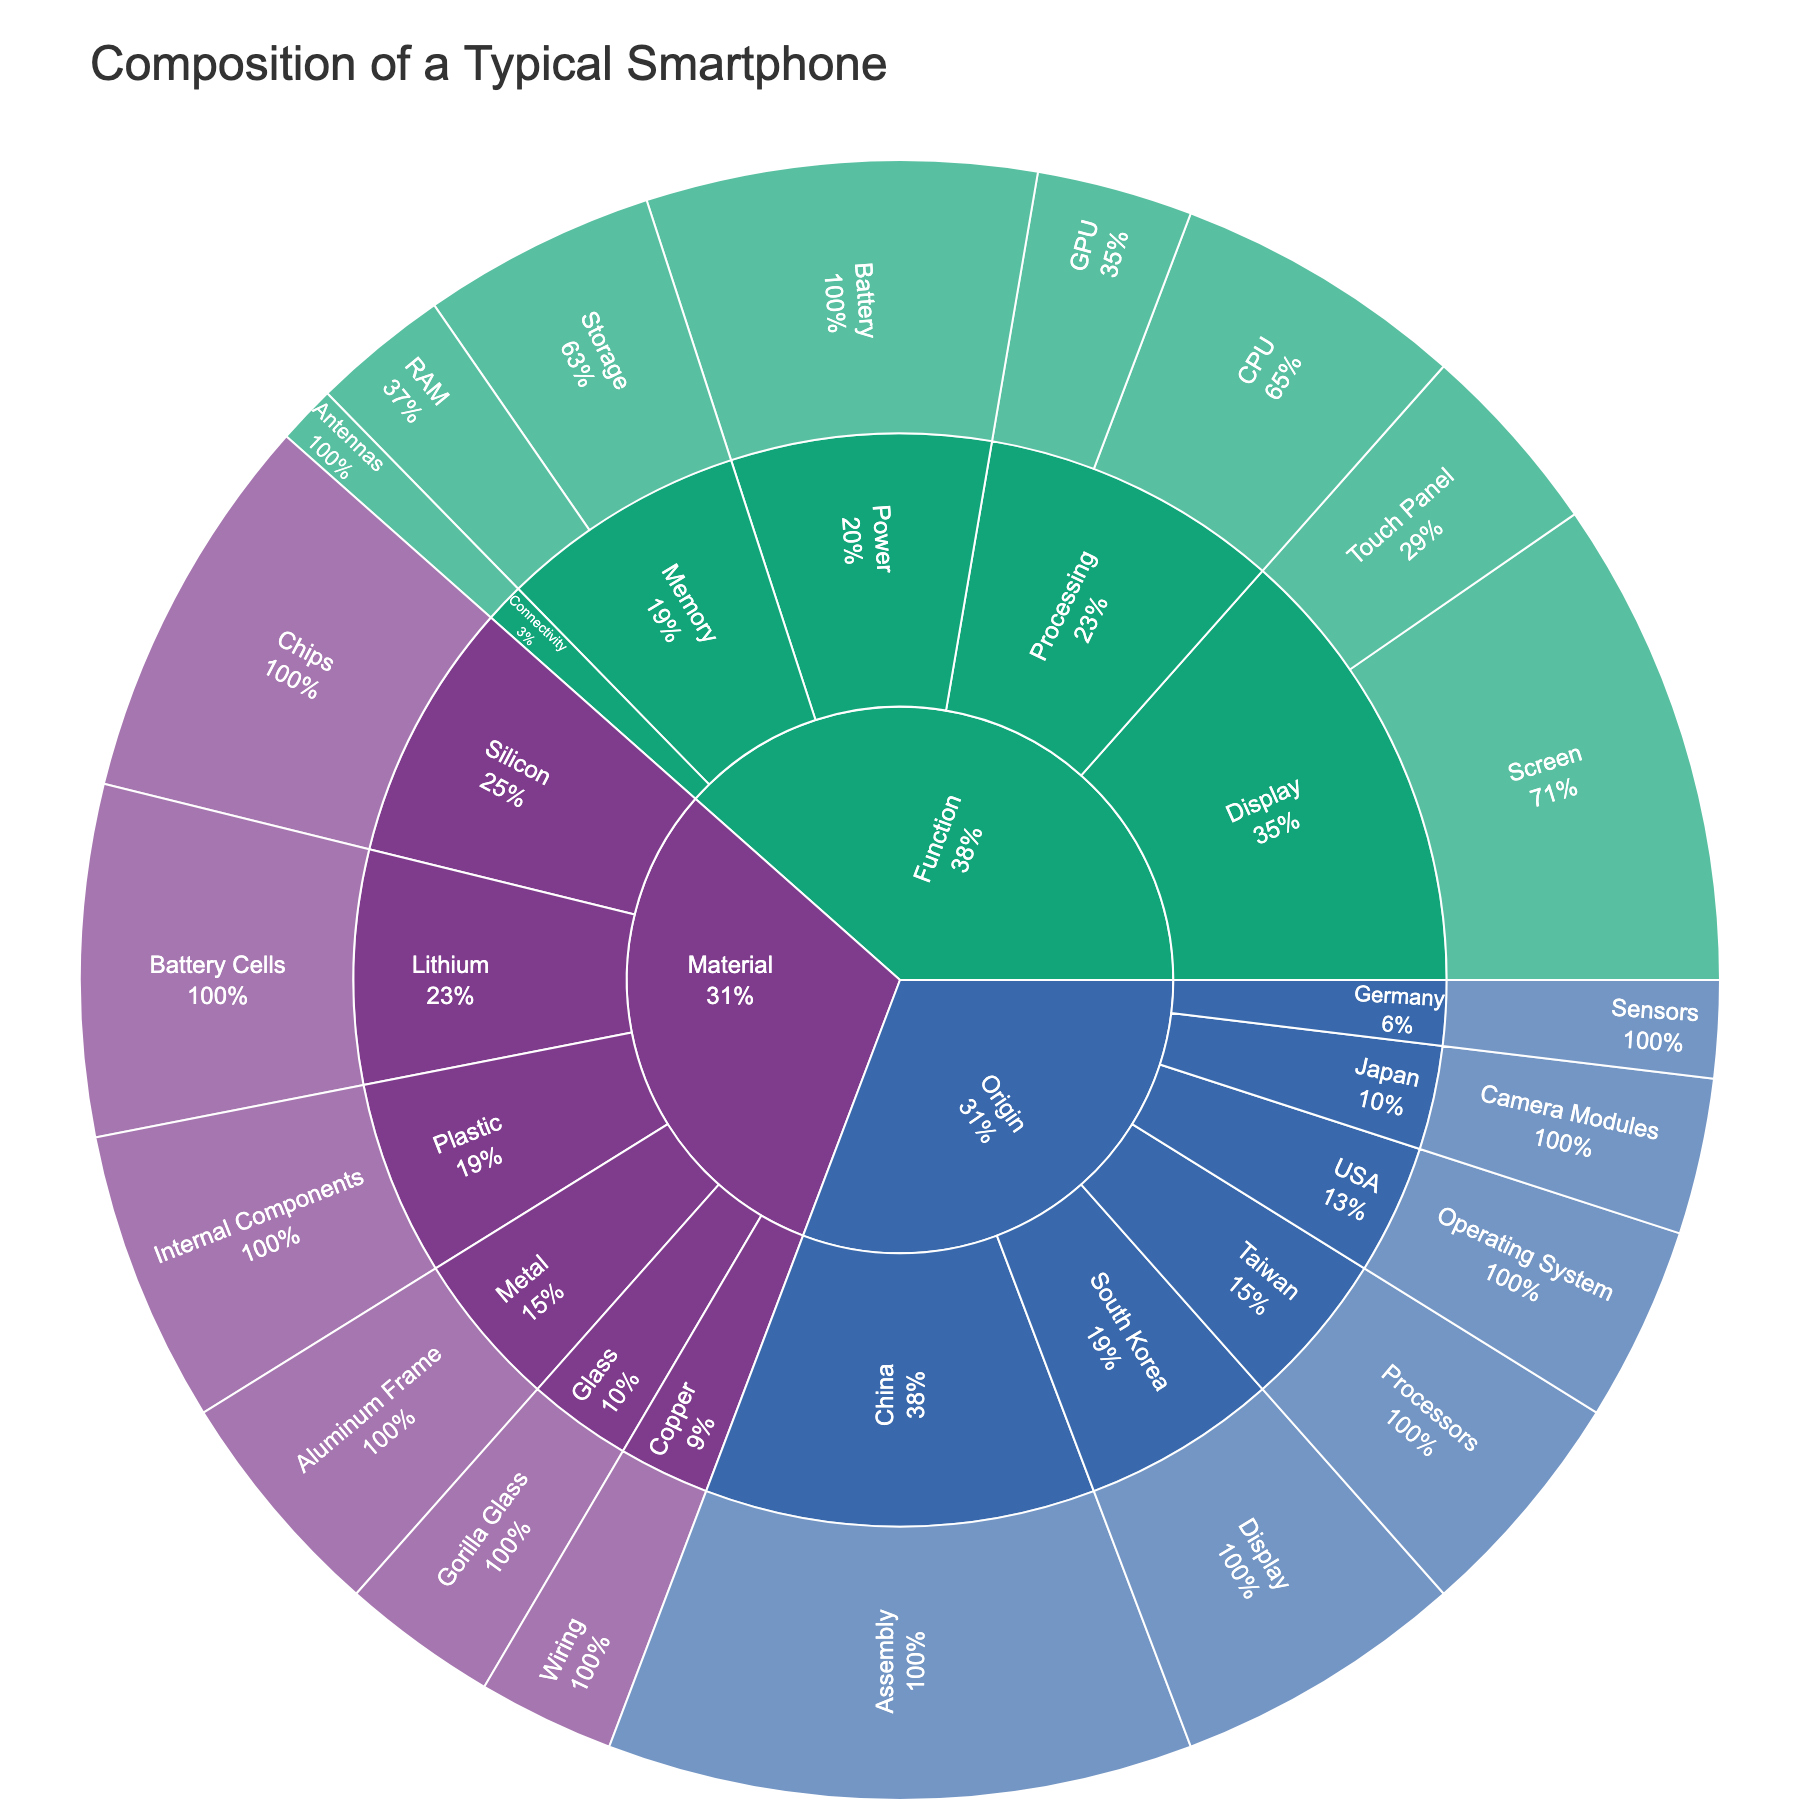What is the title of the figure? The title is generally displayed prominently at the top of the Sunburst Plot.
Answer: Composition of a Typical Smartphone Which component under the 'Display' subcategory has the largest value? Locate the 'Display' subcategory, then compare the values of its components: Screen and Touch Panel. Screen has a value of 25, which is greater than Touch Panel's value of 10.
Answer: Screen What material is most prominently used in smartphone manufacture based on the plot? Check which material has the largest slice in the 'Material' category. The 'Silicon' subcategory, particularly the 'Chips' component, has the highest value of 20.
Answer: Silicon Which country contributes the most to the smartphone's composition? Find the 'Origin' category and compare the values of the countries listed. China, with an 'Assembly' value of 30, has the largest contribution.
Answer: China Calculate the total value of all components under the 'Memory' function. Identify the components under 'Memory' (RAM and Storage), then add their values: 7 (RAM) + 12 (Storage) = 19.
Answer: 19 What's the combined value of the components made from metal and plastic? Sum the values of components listed under 'Metal' and 'Plastic': 12 (Aluminum Frame) + 15 (Internal Components) = 27.
Answer: 27 Which has a higher value, the CPU in the 'Processing' subcategory or the 'Touch Panel' in the 'Display' subcategory? Compare the values of the CPU (15) and Touch Panel (10). The CPU has a higher value.
Answer: CPU How does the contribution from Germany compare to Japan in terms of value? Compare the values of contributions from Germany (5, Sensors) and Japan (8, Camera Modules). Japan has a higher contribution.
Answer: Germany's contribution is 3 units less than Japan's What is the primary material used in the battery according to the sunburst plot? Look into the 'Battery' component under the 'Material' category. Lithium is used in the battery cells with a value of 18.
Answer: Lithium How much more value does the display function have compared to the processing function? Calculate the values of 'Display' (Screen + Touch Panel = 25 + 10 = 35) and 'Processing' (CPU + GPU = 15 + 8 = 23), then find the difference: 35 - 23 = 12.
Answer: 12 